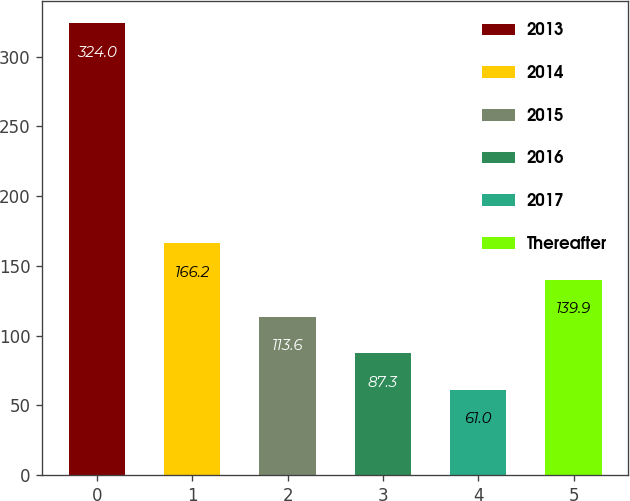Convert chart to OTSL. <chart><loc_0><loc_0><loc_500><loc_500><bar_chart><fcel>2013<fcel>2014<fcel>2015<fcel>2016<fcel>2017<fcel>Thereafter<nl><fcel>324<fcel>166.2<fcel>113.6<fcel>87.3<fcel>61<fcel>139.9<nl></chart> 